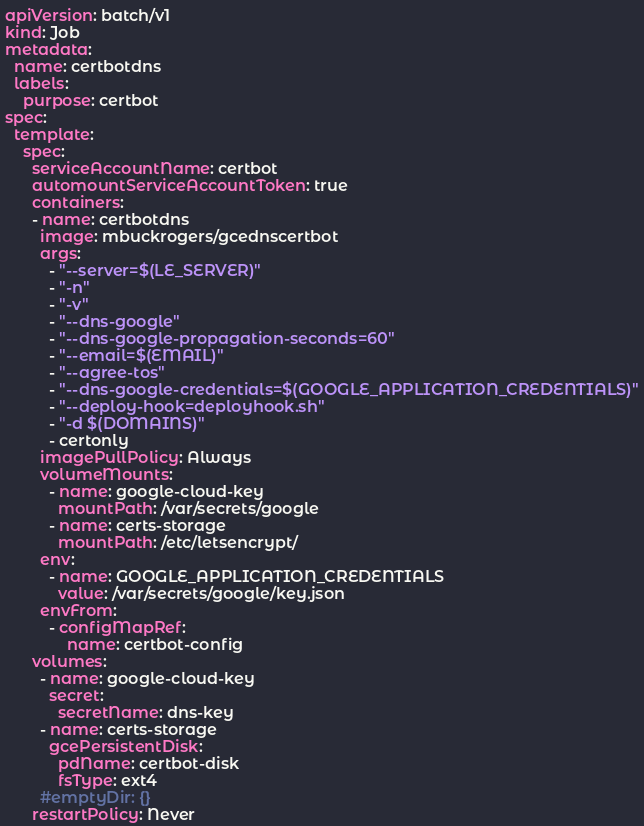Convert code to text. <code><loc_0><loc_0><loc_500><loc_500><_YAML_>apiVersion: batch/v1
kind: Job
metadata:
  name: certbotdns
  labels:
    purpose: certbot
spec:
  template:
    spec:
      serviceAccountName: certbot
      automountServiceAccountToken: true
      containers:
      - name: certbotdns
        image: mbuckrogers/gcednscertbot
        args:
          - "--server=$(LE_SERVER)"
          - "-n"
          - "-v"
          - "--dns-google"
          - "--dns-google-propagation-seconds=60"          
          - "--email=$(EMAIL)" 
          - "--agree-tos"
          - "--dns-google-credentials=$(GOOGLE_APPLICATION_CREDENTIALS)"
          - "--deploy-hook=deployhook.sh"
          - "-d $(DOMAINS)"
          - certonly
        imagePullPolicy: Always
        volumeMounts:
          - name: google-cloud-key
            mountPath: /var/secrets/google
          - name: certs-storage
            mountPath: /etc/letsencrypt/
        env:
          - name: GOOGLE_APPLICATION_CREDENTIALS
            value: /var/secrets/google/key.json
        envFrom:
          - configMapRef:
              name: certbot-config
      volumes:
        - name: google-cloud-key
          secret:
            secretName: dns-key
        - name: certs-storage
          gcePersistentDisk:
            pdName: certbot-disk
            fsType: ext4  
        #emptyDir: {}
      restartPolicy: Never</code> 